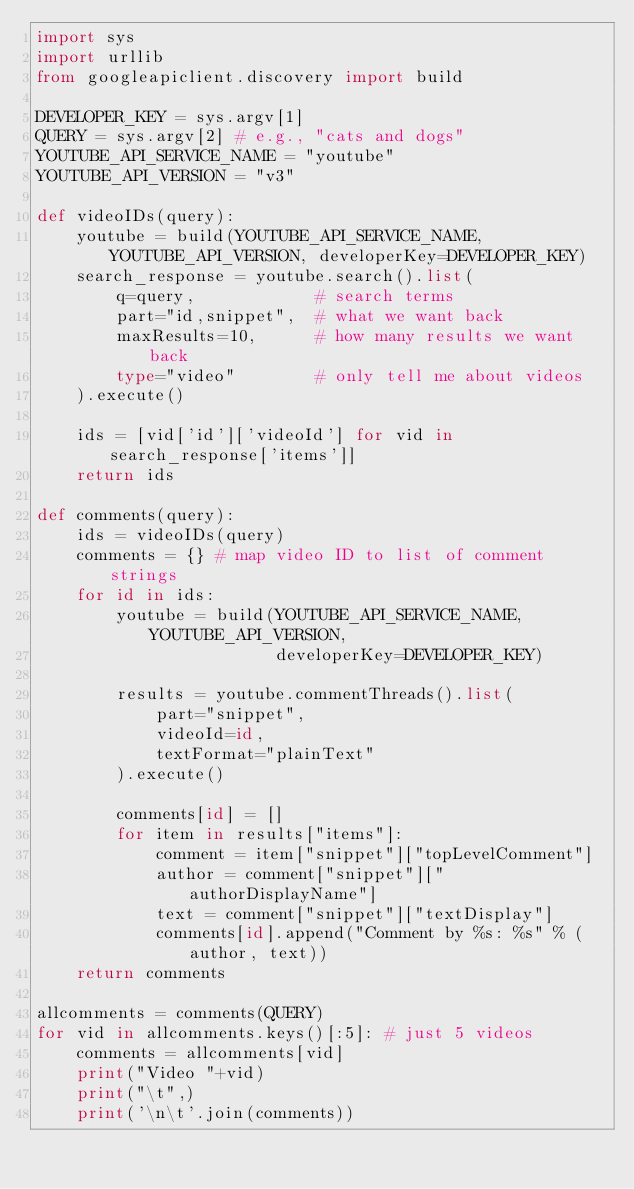<code> <loc_0><loc_0><loc_500><loc_500><_Python_>import sys
import urllib
from googleapiclient.discovery import build

DEVELOPER_KEY = sys.argv[1]
QUERY = sys.argv[2] # e.g., "cats and dogs"
YOUTUBE_API_SERVICE_NAME = "youtube"
YOUTUBE_API_VERSION = "v3"

def videoIDs(query):
    youtube = build(YOUTUBE_API_SERVICE_NAME, YOUTUBE_API_VERSION, developerKey=DEVELOPER_KEY)
    search_response = youtube.search().list(
        q=query,            # search terms
        part="id,snippet",  # what we want back
        maxResults=10,      # how many results we want back
        type="video"        # only tell me about videos
    ).execute()

    ids = [vid['id']['videoId'] for vid in search_response['items']]
    return ids

def comments(query):
    ids = videoIDs(query)
    comments = {} # map video ID to list of comment strings
    for id in ids:
        youtube = build(YOUTUBE_API_SERVICE_NAME, YOUTUBE_API_VERSION,
                        developerKey=DEVELOPER_KEY)

        results = youtube.commentThreads().list(
            part="snippet",
            videoId=id,
            textFormat="plainText"
        ).execute()

        comments[id] = []
        for item in results["items"]:
            comment = item["snippet"]["topLevelComment"]
            author = comment["snippet"]["authorDisplayName"]
            text = comment["snippet"]["textDisplay"]
            comments[id].append("Comment by %s: %s" % (author, text))
    return comments

allcomments = comments(QUERY)
for vid in allcomments.keys()[:5]: # just 5 videos
    comments = allcomments[vid]
    print("Video "+vid)
    print("\t",)
    print('\n\t'.join(comments))
</code> 